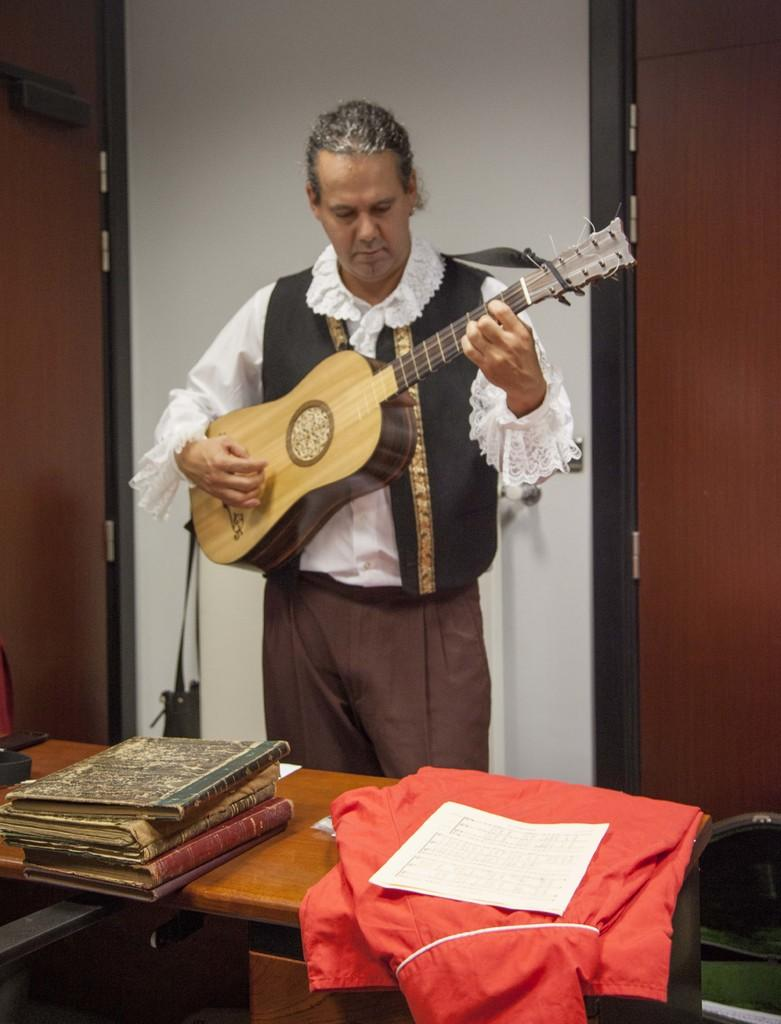Who is the main subject in the image? There is a man in the image. What is the man doing in the image? The man is standing and playing a guitar. What can be seen on the table in front of the man? There are books and clothing on the table in front of the man. Where is the man's mother in the image? There is no mention of the man's mother in the image, so we cannot determine her location. 